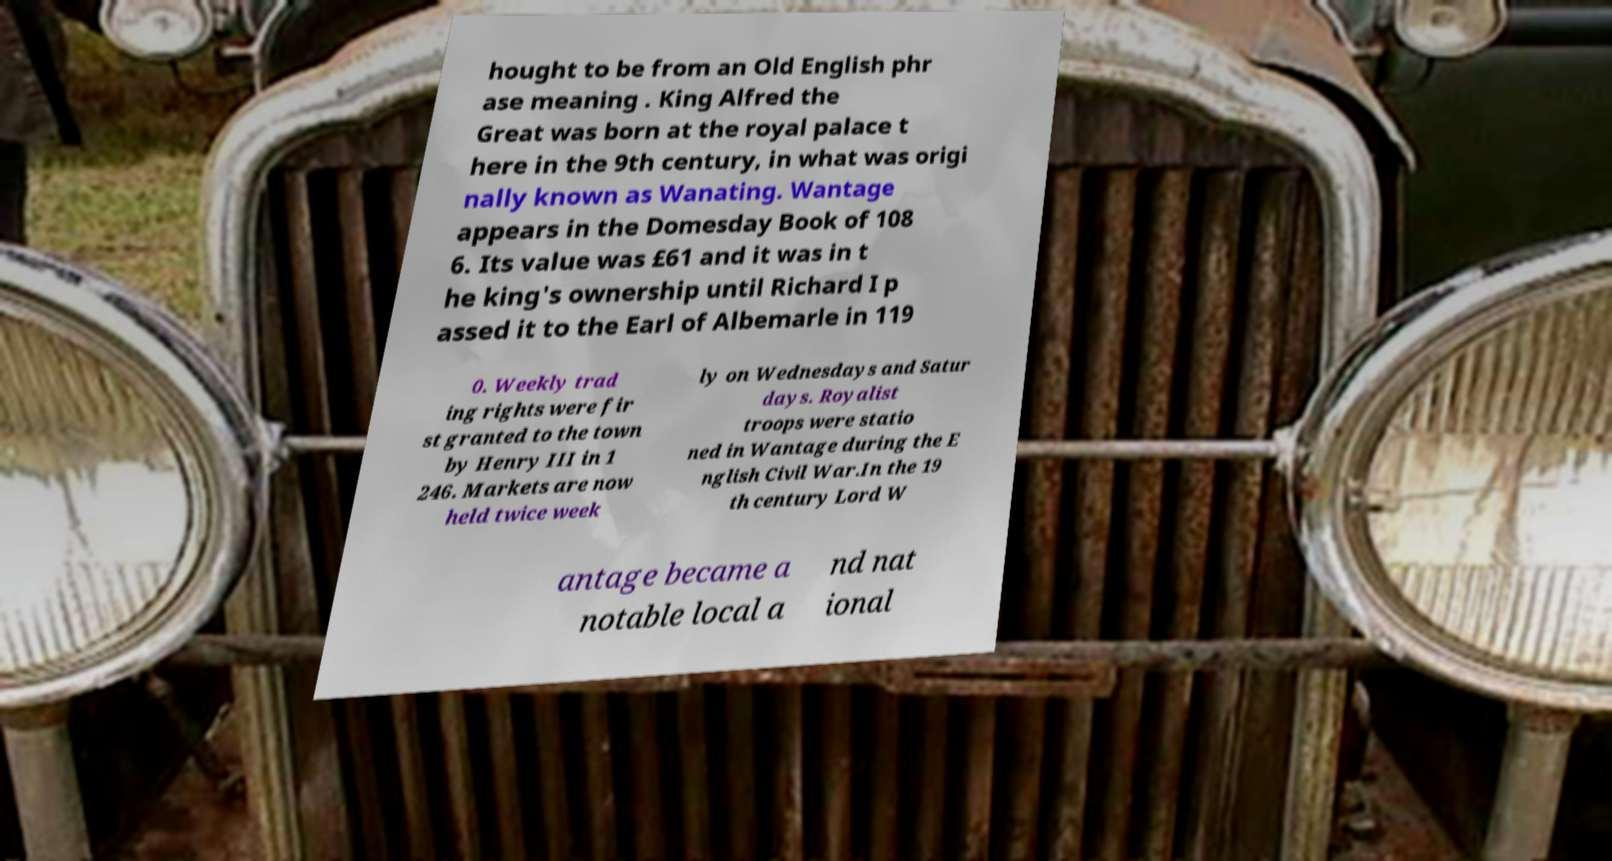There's text embedded in this image that I need extracted. Can you transcribe it verbatim? hought to be from an Old English phr ase meaning . King Alfred the Great was born at the royal palace t here in the 9th century, in what was origi nally known as Wanating. Wantage appears in the Domesday Book of 108 6. Its value was £61 and it was in t he king's ownership until Richard I p assed it to the Earl of Albemarle in 119 0. Weekly trad ing rights were fir st granted to the town by Henry III in 1 246. Markets are now held twice week ly on Wednesdays and Satur days. Royalist troops were statio ned in Wantage during the E nglish Civil War.In the 19 th century Lord W antage became a notable local a nd nat ional 